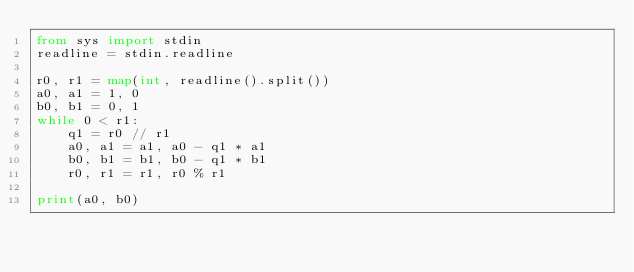Convert code to text. <code><loc_0><loc_0><loc_500><loc_500><_Python_>from sys import stdin
readline = stdin.readline

r0, r1 = map(int, readline().split())
a0, a1 = 1, 0
b0, b1 = 0, 1
while 0 < r1:
    q1 = r0 // r1
    a0, a1 = a1, a0 - q1 * a1
    b0, b1 = b1, b0 - q1 * b1    
    r0, r1 = r1, r0 % r1

print(a0, b0)</code> 